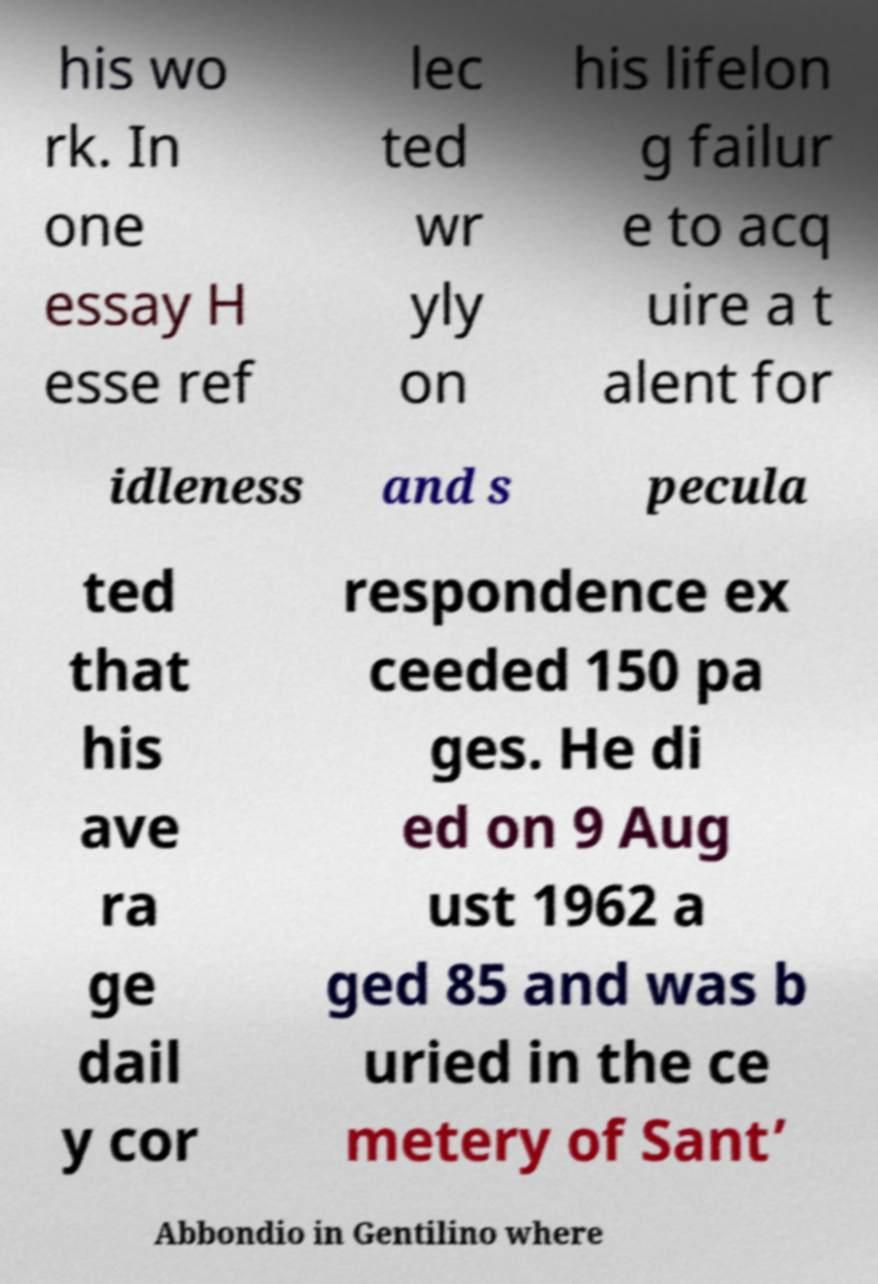Can you accurately transcribe the text from the provided image for me? his wo rk. In one essay H esse ref lec ted wr yly on his lifelon g failur e to acq uire a t alent for idleness and s pecula ted that his ave ra ge dail y cor respondence ex ceeded 150 pa ges. He di ed on 9 Aug ust 1962 a ged 85 and was b uried in the ce metery of Sant’ Abbondio in Gentilino where 